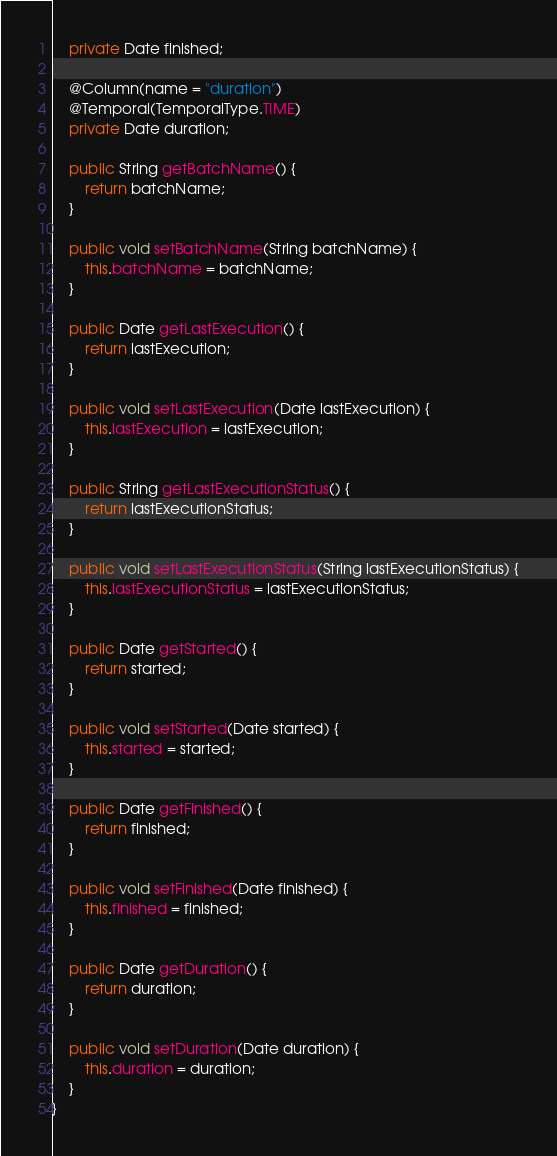Convert code to text. <code><loc_0><loc_0><loc_500><loc_500><_Java_>	private Date finished;
	
	@Column(name = "duration")
	@Temporal(TemporalType.TIME)
	private Date duration;

	public String getBatchName() {
		return batchName;
	}

	public void setBatchName(String batchName) {
		this.batchName = batchName;
	}

	public Date getLastExecution() {
		return lastExecution;
	}

	public void setLastExecution(Date lastExecution) {
		this.lastExecution = lastExecution;
	}

	public String getLastExecutionStatus() {
		return lastExecutionStatus;
	}

	public void setLastExecutionStatus(String lastExecutionStatus) {
		this.lastExecutionStatus = lastExecutionStatus;
	}

	public Date getStarted() {
		return started;
	}

	public void setStarted(Date started) {
		this.started = started;
	}

	public Date getFinished() {
		return finished;
	}

	public void setFinished(Date finished) {
		this.finished = finished;
	}

	public Date getDuration() {
		return duration;
	}

	public void setDuration(Date duration) {
		this.duration = duration;
	}
}
</code> 